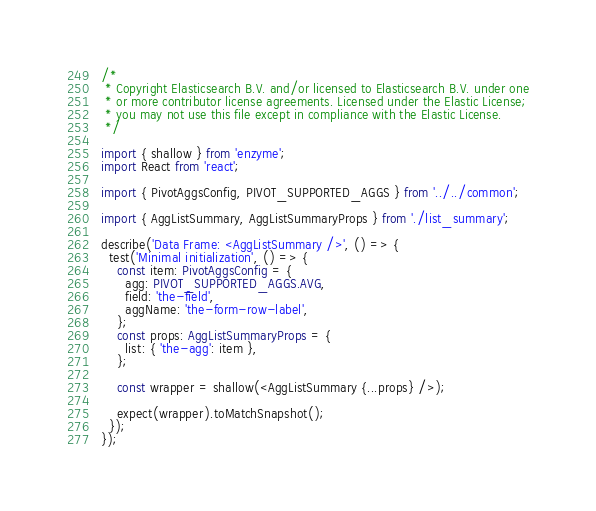Convert code to text. <code><loc_0><loc_0><loc_500><loc_500><_TypeScript_>/*
 * Copyright Elasticsearch B.V. and/or licensed to Elasticsearch B.V. under one
 * or more contributor license agreements. Licensed under the Elastic License;
 * you may not use this file except in compliance with the Elastic License.
 */

import { shallow } from 'enzyme';
import React from 'react';

import { PivotAggsConfig, PIVOT_SUPPORTED_AGGS } from '../../common';

import { AggListSummary, AggListSummaryProps } from './list_summary';

describe('Data Frame: <AggListSummary />', () => {
  test('Minimal initialization', () => {
    const item: PivotAggsConfig = {
      agg: PIVOT_SUPPORTED_AGGS.AVG,
      field: 'the-field',
      aggName: 'the-form-row-label',
    };
    const props: AggListSummaryProps = {
      list: { 'the-agg': item },
    };

    const wrapper = shallow(<AggListSummary {...props} />);

    expect(wrapper).toMatchSnapshot();
  });
});
</code> 